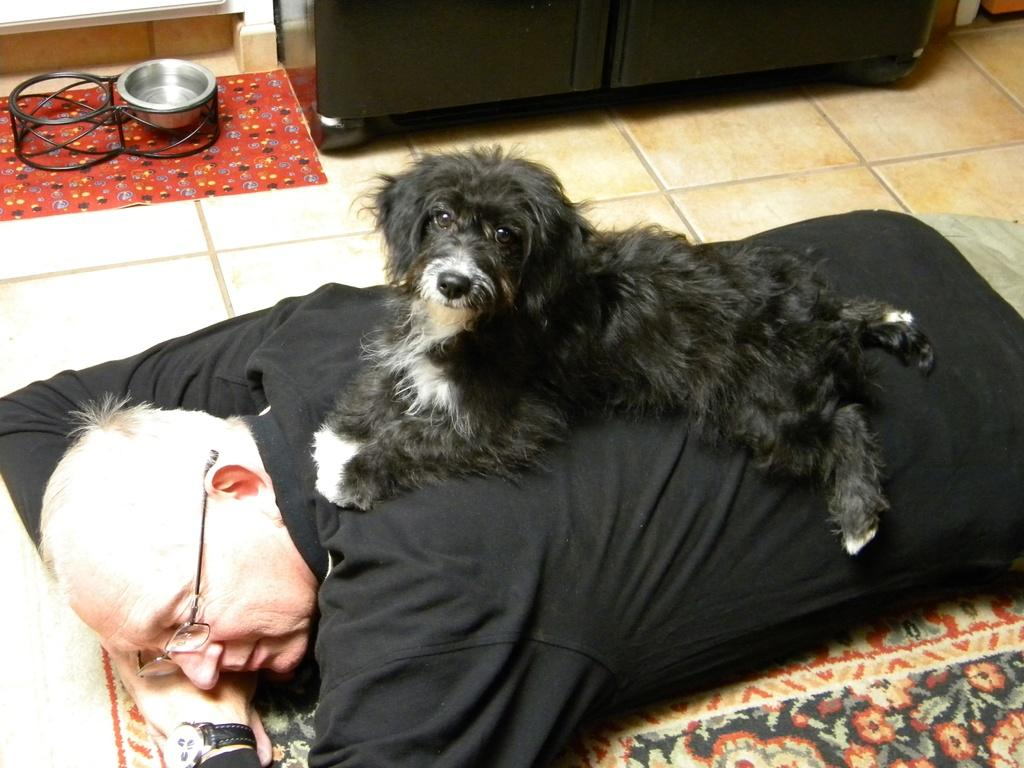What is the man doing in the image? The man is lying on the floor on a carpet. What is on top of the man in the image? There is a dog sitting on the man. What can be seen in the background of the image? There is a bowl placed on the cloth in the background and a cupboard in the background. What songs is the man singing in the image? There is no indication in the image that the man is singing in the image. Can you describe the beetle that is crawling on the dog's back? There is no beetle present in the image; only the man, the dog, and the background objects are visible. 